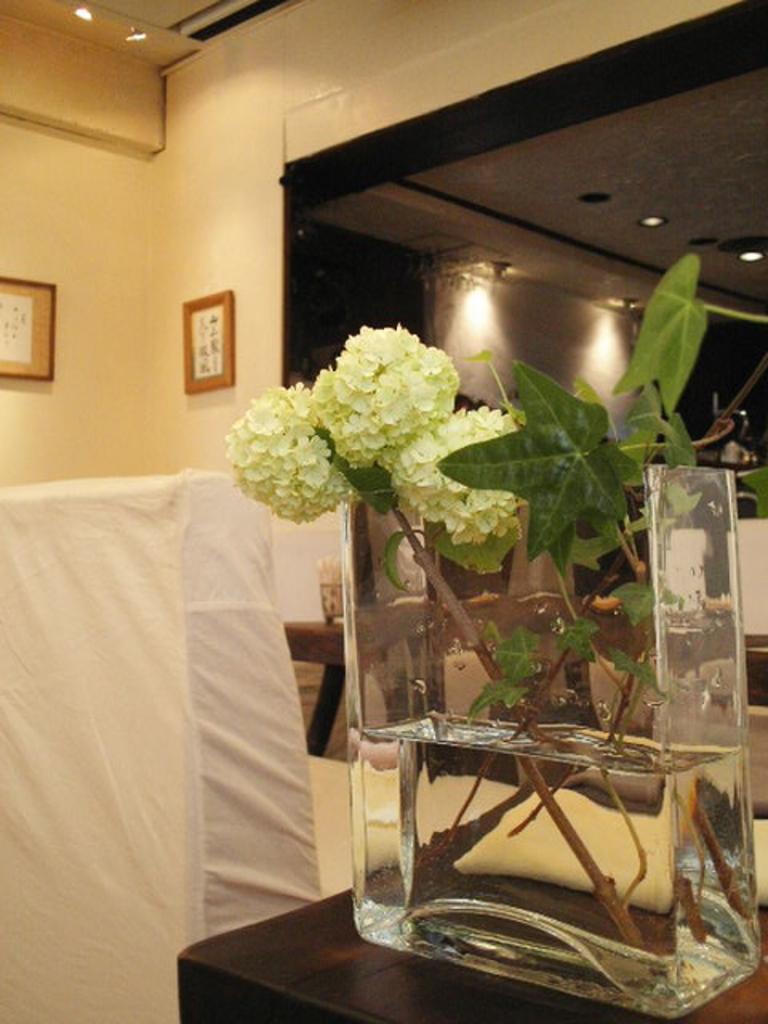Please provide a concise description of this image. There is table with with flower vase on it with some water on that arranged with some leaves and white flowers. In front of that there are chairs covered with cloth and behind the tables there is a glass wall in it. below that we can see small part of table with tissue box on it and there is a frame sticked on wall. 